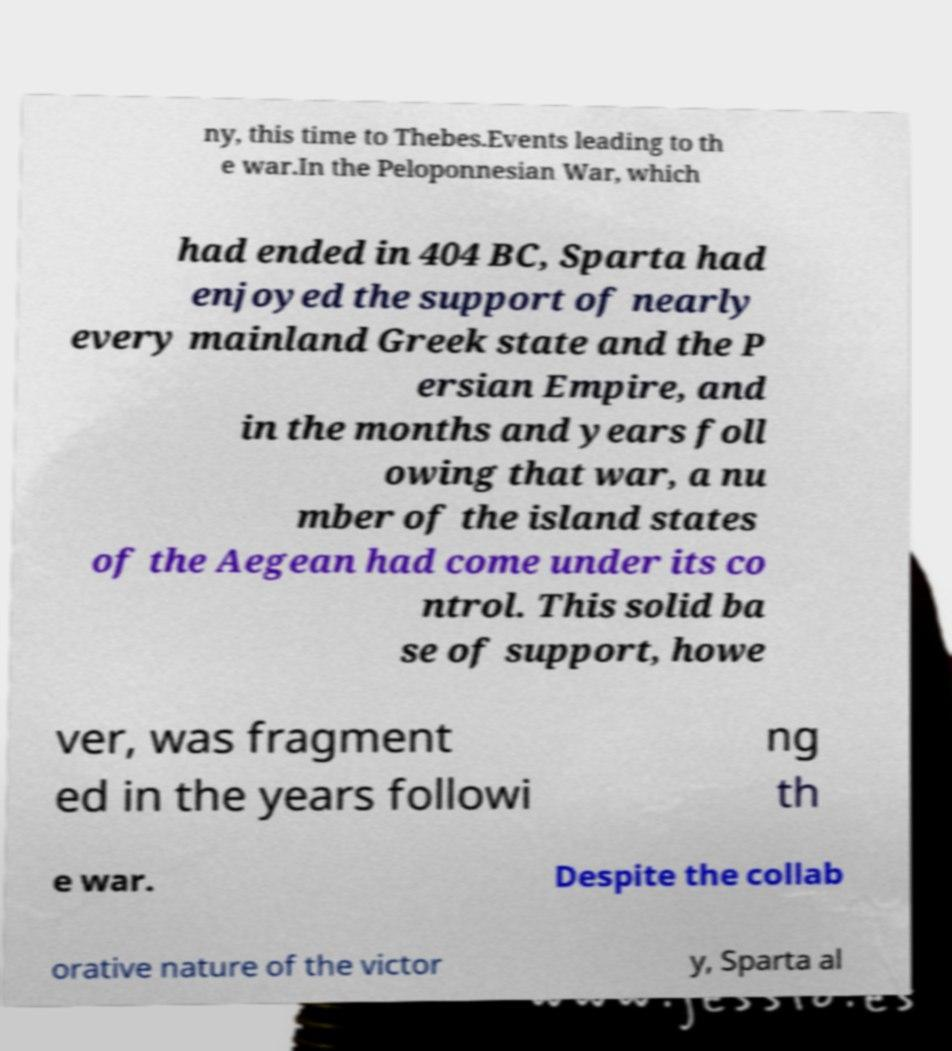Can you accurately transcribe the text from the provided image for me? ny, this time to Thebes.Events leading to th e war.In the Peloponnesian War, which had ended in 404 BC, Sparta had enjoyed the support of nearly every mainland Greek state and the P ersian Empire, and in the months and years foll owing that war, a nu mber of the island states of the Aegean had come under its co ntrol. This solid ba se of support, howe ver, was fragment ed in the years followi ng th e war. Despite the collab orative nature of the victor y, Sparta al 